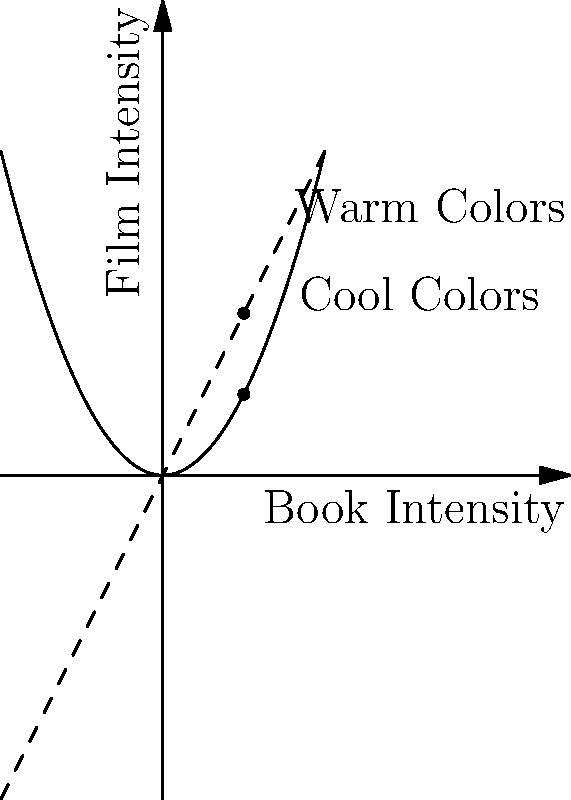How does the film's color palette compare to the mood described in your book, particularly in scenes of increasing emotional intensity? 1. Analyze the graph:
   - The x-axis represents the intensity of emotions in the book.
   - The y-axis represents the intensity of colors in the film.
   - The solid curve represents cool colors (blues, greens).
   - The dashed line represents warm colors (reds, oranges).

2. Interpret the curves:
   - The cool color curve (solid) is exponential, showing a rapid increase in intensity.
   - The warm color curve (dashed) is linear, showing a steady increase.

3. Compare to the book:
   - As emotional intensity increases in the book (moving right on x-axis), both color intensities increase in the film.
   - Cool colors increase more rapidly than warm colors.

4. Analyze the mood:
   - Cool colors often represent calmness, sadness, or introspection.
   - Warm colors often represent passion, anger, or excitement.

5. Draw conclusions:
   - The film seems to emphasize cooler tones for high-intensity scenes.
   - This suggests a focus on introspective or melancholic moods during emotionally charged moments.
   - The choice may alter the mood from the book if warm emotions were more prevalent in the text.
Answer: The film emphasizes cool colors for high-intensity scenes, potentially shifting the mood towards introspection or melancholy compared to the book. 